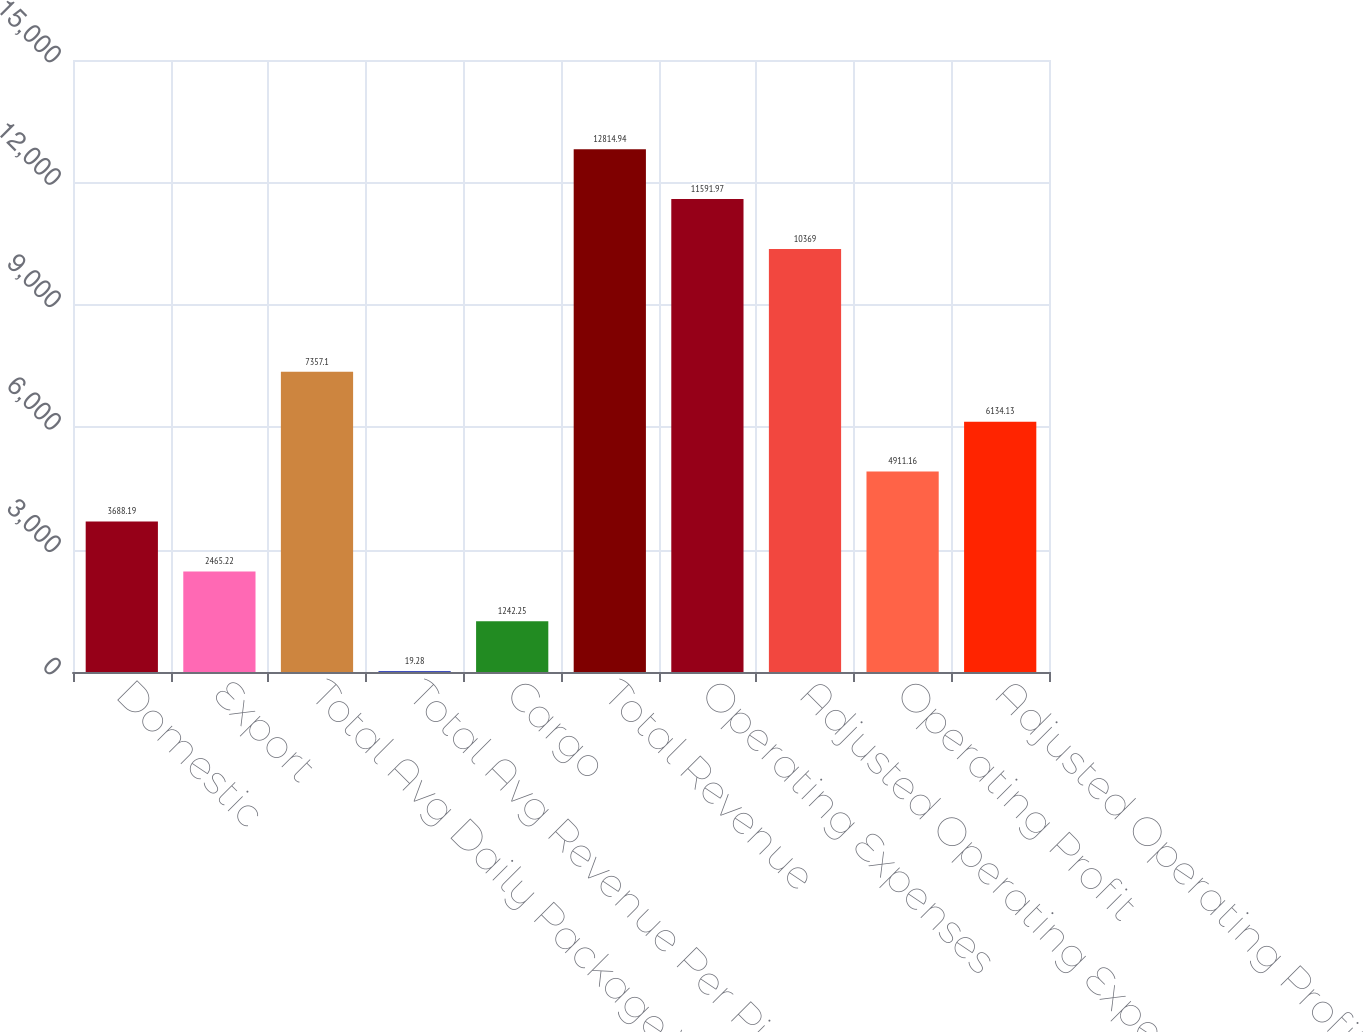<chart> <loc_0><loc_0><loc_500><loc_500><bar_chart><fcel>Domestic<fcel>Export<fcel>Total Avg Daily Package Volume<fcel>Total Avg Revenue Per Piece<fcel>Cargo<fcel>Total Revenue<fcel>Operating Expenses<fcel>Adjusted Operating Expenses<fcel>Operating Profit<fcel>Adjusted Operating Profit<nl><fcel>3688.19<fcel>2465.22<fcel>7357.1<fcel>19.28<fcel>1242.25<fcel>12814.9<fcel>11592<fcel>10369<fcel>4911.16<fcel>6134.13<nl></chart> 